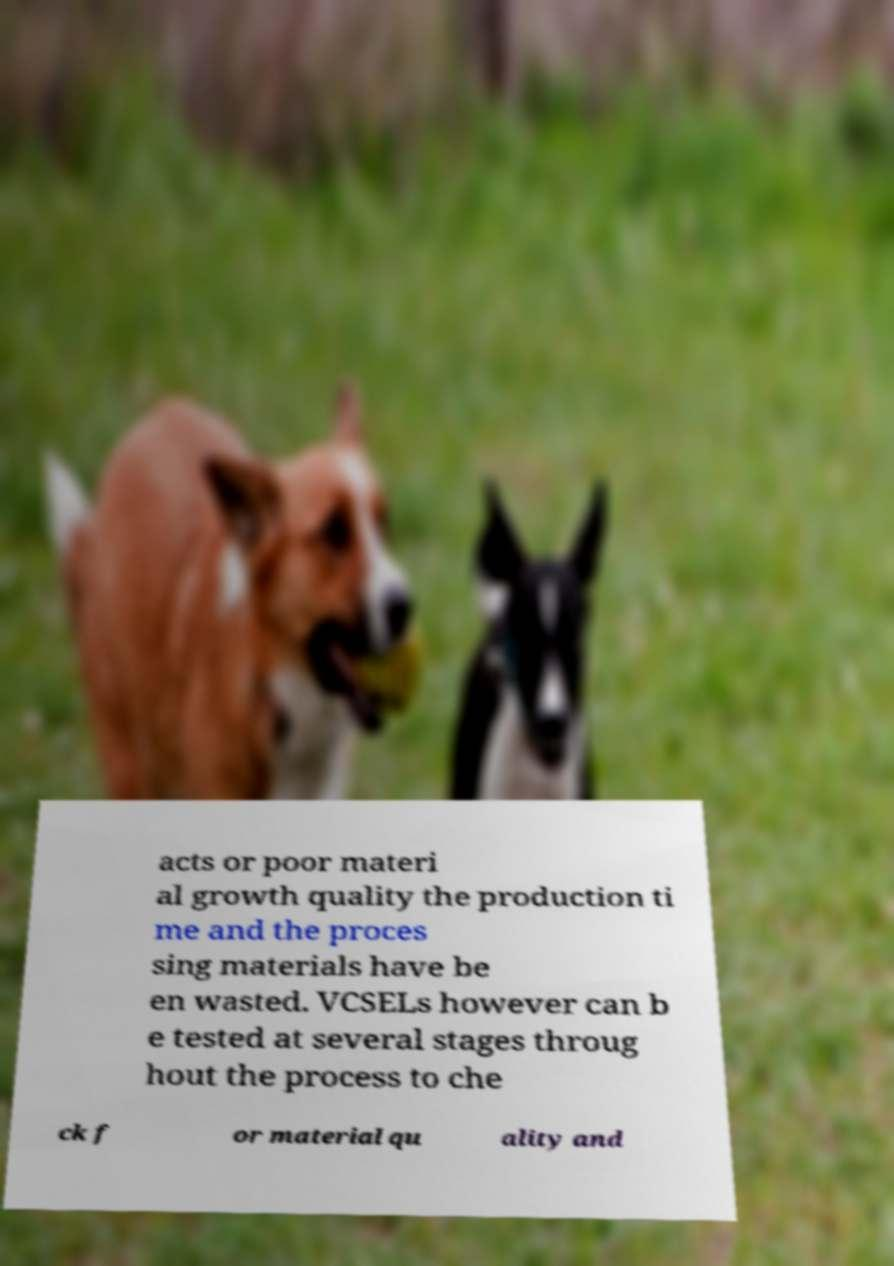For documentation purposes, I need the text within this image transcribed. Could you provide that? acts or poor materi al growth quality the production ti me and the proces sing materials have be en wasted. VCSELs however can b e tested at several stages throug hout the process to che ck f or material qu ality and 